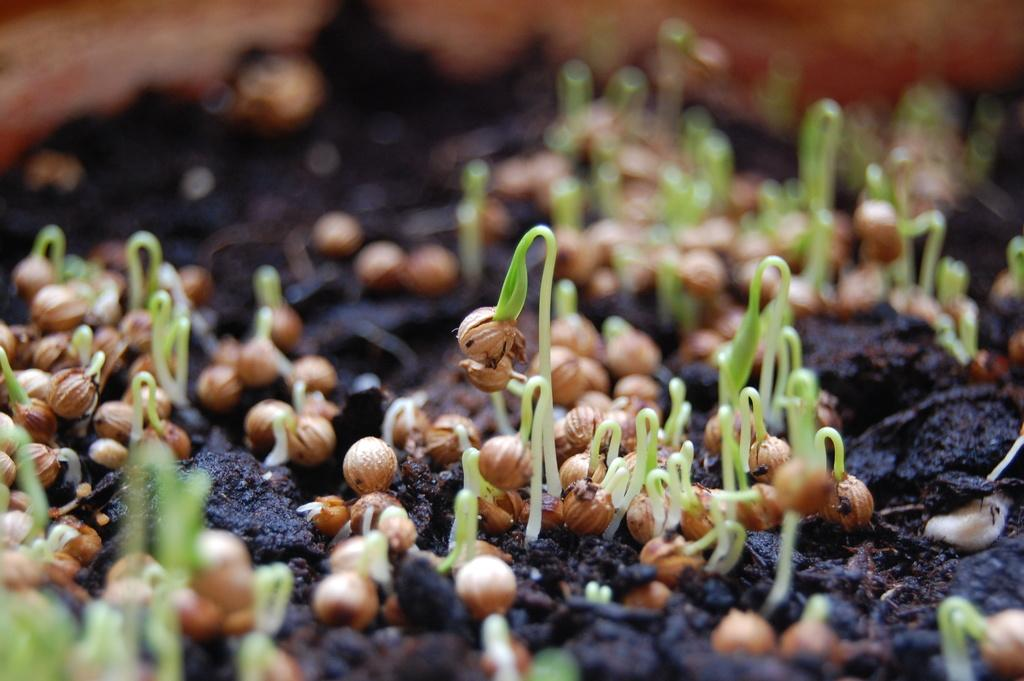What is the primary substance visible in the image? There is soil in the image. What is growing on the soil? There are seeds with seedlings on the soil. Can you describe the background of the image? The background of the image is blurred. What type of treatment is being administered to the uncle in the image? There is no uncle or treatment present in the image. 